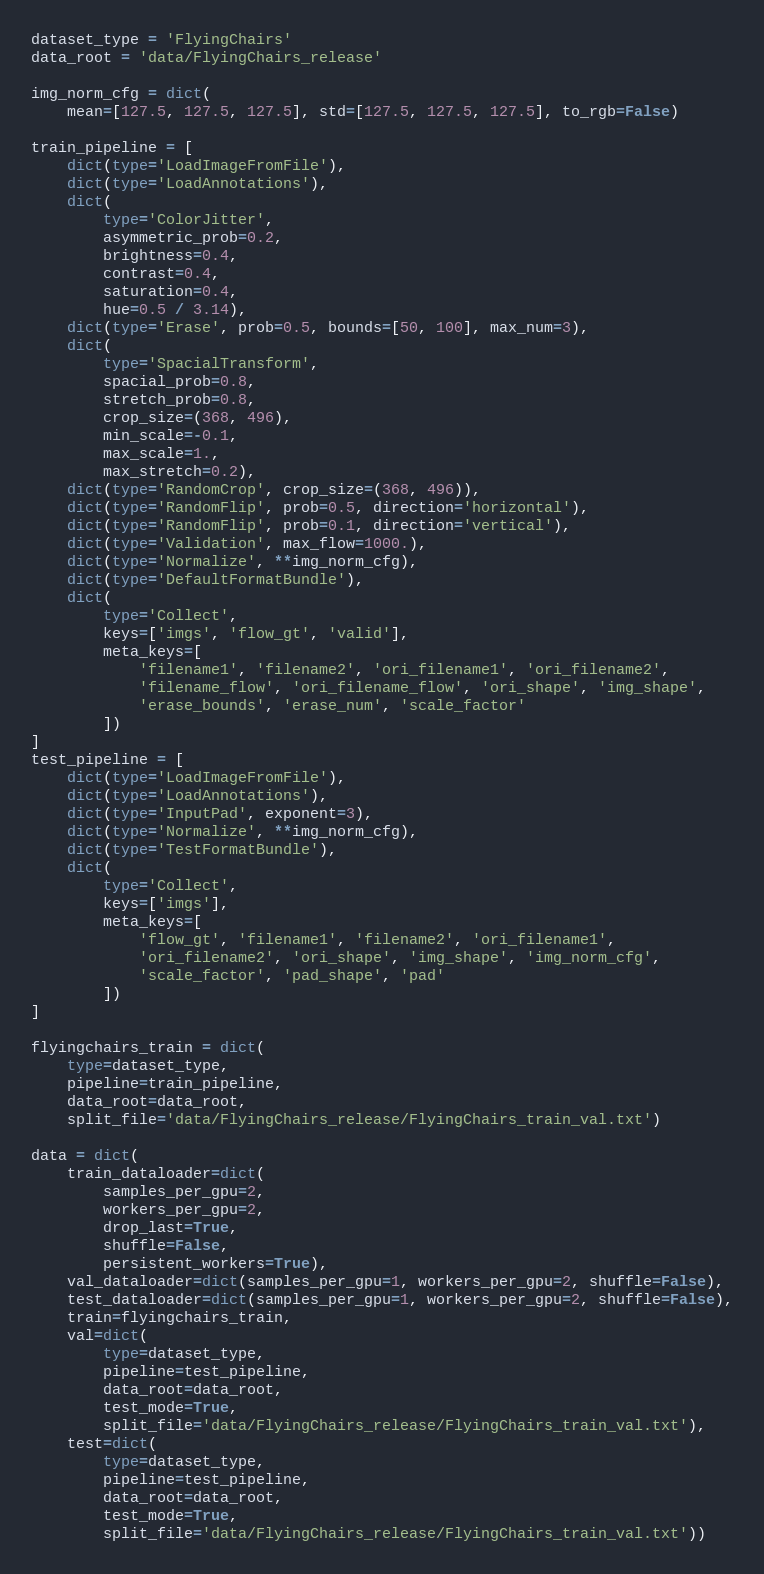<code> <loc_0><loc_0><loc_500><loc_500><_Python_>dataset_type = 'FlyingChairs'
data_root = 'data/FlyingChairs_release'

img_norm_cfg = dict(
    mean=[127.5, 127.5, 127.5], std=[127.5, 127.5, 127.5], to_rgb=False)

train_pipeline = [
    dict(type='LoadImageFromFile'),
    dict(type='LoadAnnotations'),
    dict(
        type='ColorJitter',
        asymmetric_prob=0.2,
        brightness=0.4,
        contrast=0.4,
        saturation=0.4,
        hue=0.5 / 3.14),
    dict(type='Erase', prob=0.5, bounds=[50, 100], max_num=3),
    dict(
        type='SpacialTransform',
        spacial_prob=0.8,
        stretch_prob=0.8,
        crop_size=(368, 496),
        min_scale=-0.1,
        max_scale=1.,
        max_stretch=0.2),
    dict(type='RandomCrop', crop_size=(368, 496)),
    dict(type='RandomFlip', prob=0.5, direction='horizontal'),
    dict(type='RandomFlip', prob=0.1, direction='vertical'),
    dict(type='Validation', max_flow=1000.),
    dict(type='Normalize', **img_norm_cfg),
    dict(type='DefaultFormatBundle'),
    dict(
        type='Collect',
        keys=['imgs', 'flow_gt', 'valid'],
        meta_keys=[
            'filename1', 'filename2', 'ori_filename1', 'ori_filename2',
            'filename_flow', 'ori_filename_flow', 'ori_shape', 'img_shape',
            'erase_bounds', 'erase_num', 'scale_factor'
        ])
]
test_pipeline = [
    dict(type='LoadImageFromFile'),
    dict(type='LoadAnnotations'),
    dict(type='InputPad', exponent=3),
    dict(type='Normalize', **img_norm_cfg),
    dict(type='TestFormatBundle'),
    dict(
        type='Collect',
        keys=['imgs'],
        meta_keys=[
            'flow_gt', 'filename1', 'filename2', 'ori_filename1',
            'ori_filename2', 'ori_shape', 'img_shape', 'img_norm_cfg',
            'scale_factor', 'pad_shape', 'pad'
        ])
]

flyingchairs_train = dict(
    type=dataset_type,
    pipeline=train_pipeline,
    data_root=data_root,
    split_file='data/FlyingChairs_release/FlyingChairs_train_val.txt')

data = dict(
    train_dataloader=dict(
        samples_per_gpu=2,
        workers_per_gpu=2,
        drop_last=True,
        shuffle=False,
        persistent_workers=True),
    val_dataloader=dict(samples_per_gpu=1, workers_per_gpu=2, shuffle=False),
    test_dataloader=dict(samples_per_gpu=1, workers_per_gpu=2, shuffle=False),
    train=flyingchairs_train,
    val=dict(
        type=dataset_type,
        pipeline=test_pipeline,
        data_root=data_root,
        test_mode=True,
        split_file='data/FlyingChairs_release/FlyingChairs_train_val.txt'),
    test=dict(
        type=dataset_type,
        pipeline=test_pipeline,
        data_root=data_root,
        test_mode=True,
        split_file='data/FlyingChairs_release/FlyingChairs_train_val.txt'))
</code> 